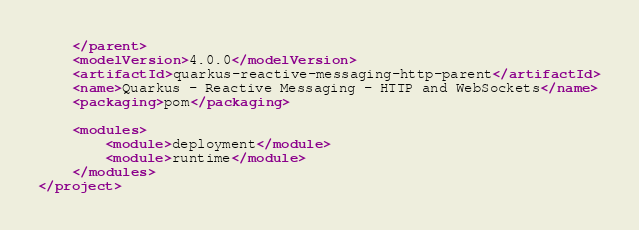<code> <loc_0><loc_0><loc_500><loc_500><_XML_>    </parent>
    <modelVersion>4.0.0</modelVersion>
    <artifactId>quarkus-reactive-messaging-http-parent</artifactId>
    <name>Quarkus - Reactive Messaging - HTTP and WebSockets</name>
    <packaging>pom</packaging>

    <modules>
        <module>deployment</module>
        <module>runtime</module>
    </modules>
</project>
</code> 